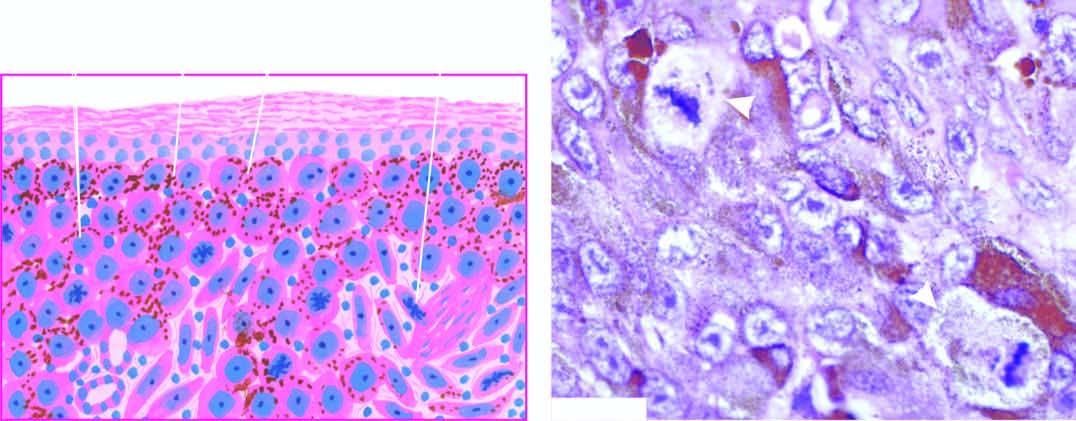what are tumour cells resembling epithelioid cells with pleomorphic nuclei and prominent nucleoli seen as in the dermis?
Answer the question using a single word or phrase. Solid masses 